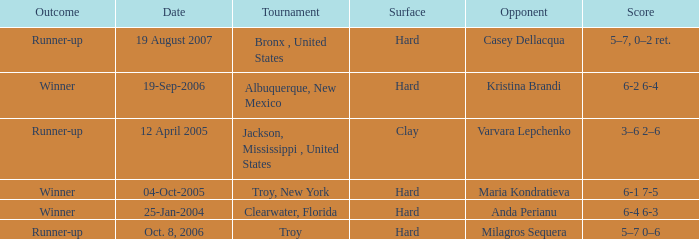What is the final score of the tournament played in Clearwater, Florida? 6-4 6-3. 